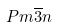Convert formula to latex. <formula><loc_0><loc_0><loc_500><loc_500>P m \overline { 3 } n</formula> 